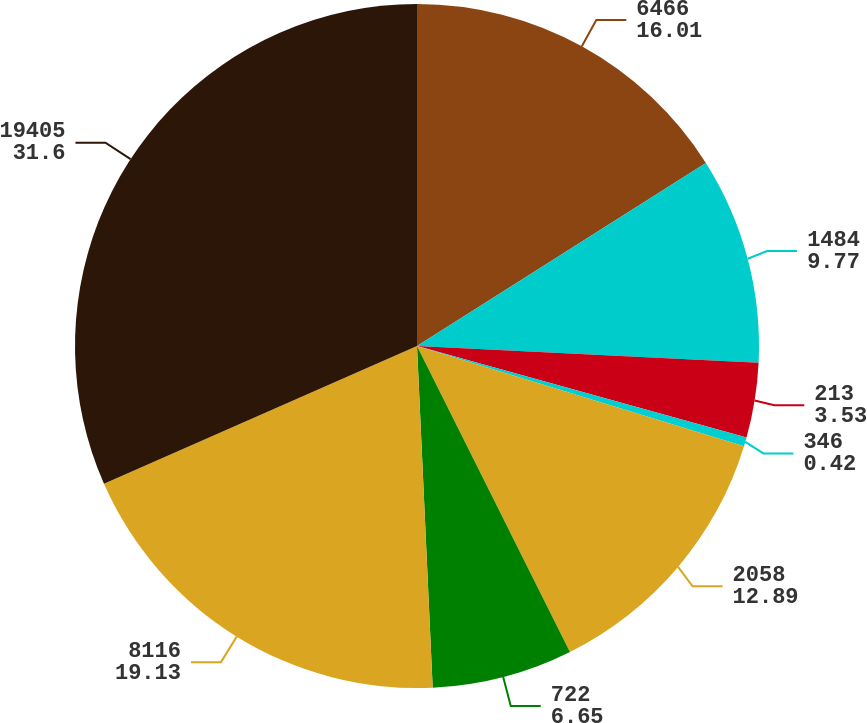Convert chart. <chart><loc_0><loc_0><loc_500><loc_500><pie_chart><fcel>6466<fcel>1484<fcel>213<fcel>346<fcel>2058<fcel>722<fcel>8116<fcel>19405<nl><fcel>16.01%<fcel>9.77%<fcel>3.53%<fcel>0.42%<fcel>12.89%<fcel>6.65%<fcel>19.13%<fcel>31.6%<nl></chart> 